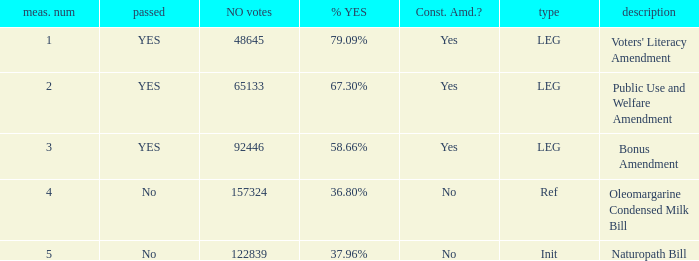What is the measure number for the init type?  5.0. I'm looking to parse the entire table for insights. Could you assist me with that? {'header': ['meas. num', 'passed', 'NO votes', '% YES', 'Const. Amd.?', 'type', 'description'], 'rows': [['1', 'YES', '48645', '79.09%', 'Yes', 'LEG', "Voters' Literacy Amendment"], ['2', 'YES', '65133', '67.30%', 'Yes', 'LEG', 'Public Use and Welfare Amendment'], ['3', 'YES', '92446', '58.66%', 'Yes', 'LEG', 'Bonus Amendment'], ['4', 'No', '157324', '36.80%', 'No', 'Ref', 'Oleomargarine Condensed Milk Bill'], ['5', 'No', '122839', '37.96%', 'No', 'Init', 'Naturopath Bill']]} 